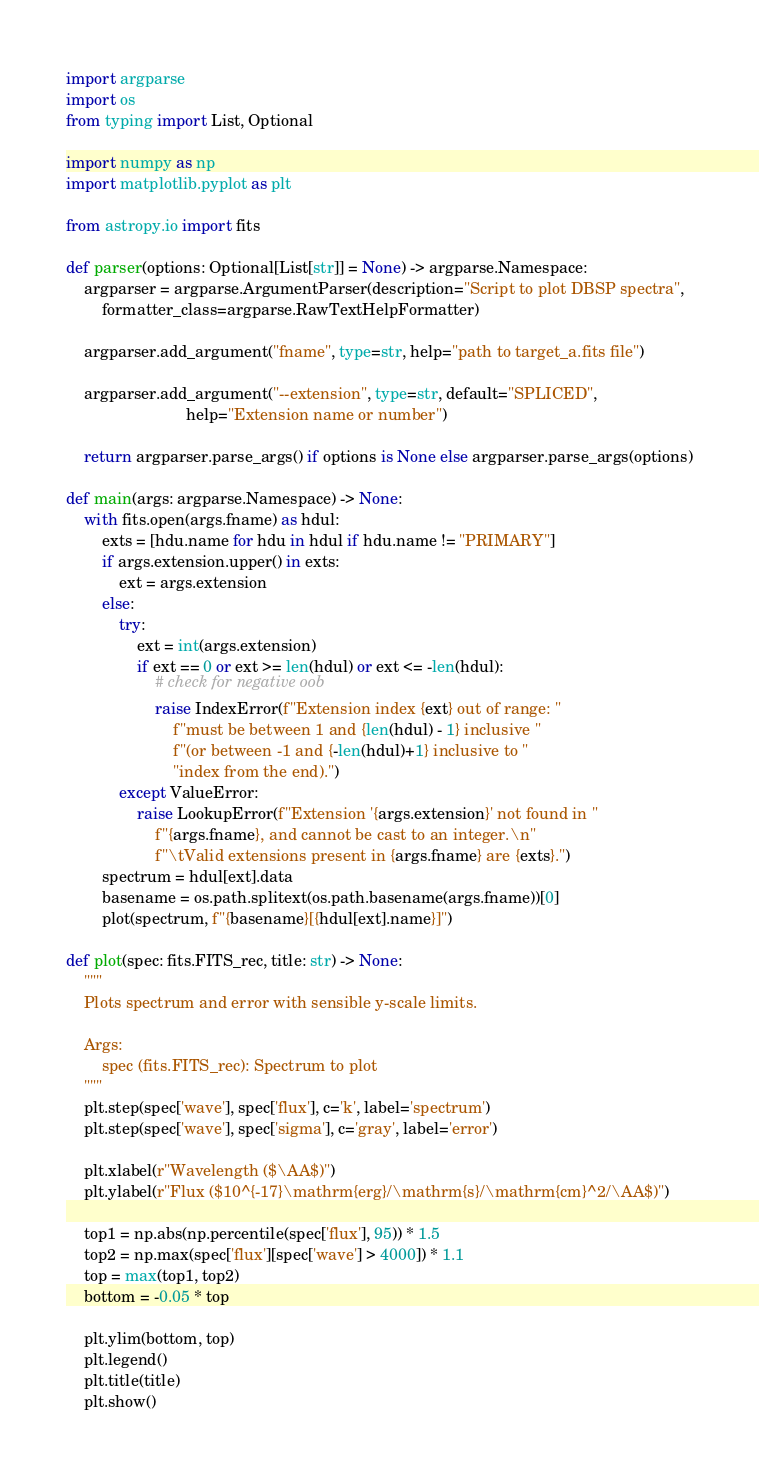<code> <loc_0><loc_0><loc_500><loc_500><_Python_>import argparse
import os
from typing import List, Optional

import numpy as np
import matplotlib.pyplot as plt

from astropy.io import fits

def parser(options: Optional[List[str]] = None) -> argparse.Namespace:
    argparser = argparse.ArgumentParser(description="Script to plot DBSP spectra",
        formatter_class=argparse.RawTextHelpFormatter)

    argparser.add_argument("fname", type=str, help="path to target_a.fits file")

    argparser.add_argument("--extension", type=str, default="SPLICED",
                           help="Extension name or number")

    return argparser.parse_args() if options is None else argparser.parse_args(options)

def main(args: argparse.Namespace) -> None:
    with fits.open(args.fname) as hdul:
        exts = [hdu.name for hdu in hdul if hdu.name != "PRIMARY"]
        if args.extension.upper() in exts:
            ext = args.extension
        else:
            try:
                ext = int(args.extension)
                if ext == 0 or ext >= len(hdul) or ext <= -len(hdul):
                    # check for negative oob
                    raise IndexError(f"Extension index {ext} out of range: "
                        f"must be between 1 and {len(hdul) - 1} inclusive "
                        f"(or between -1 and {-len(hdul)+1} inclusive to "
                        "index from the end).")
            except ValueError:
                raise LookupError(f"Extension '{args.extension}' not found in "
                    f"{args.fname}, and cannot be cast to an integer.\n"
                    f"\tValid extensions present in {args.fname} are {exts}.")
        spectrum = hdul[ext].data
        basename = os.path.splitext(os.path.basename(args.fname))[0]
        plot(spectrum, f"{basename}[{hdul[ext].name}]")

def plot(spec: fits.FITS_rec, title: str) -> None:
    """
    Plots spectrum and error with sensible y-scale limits.

    Args:
        spec (fits.FITS_rec): Spectrum to plot
    """
    plt.step(spec['wave'], spec['flux'], c='k', label='spectrum')
    plt.step(spec['wave'], spec['sigma'], c='gray', label='error')

    plt.xlabel(r"Wavelength ($\AA$)")
    plt.ylabel(r"Flux ($10^{-17}\mathrm{erg}/\mathrm{s}/\mathrm{cm}^2/\AA$)")

    top1 = np.abs(np.percentile(spec['flux'], 95)) * 1.5
    top2 = np.max(spec['flux'][spec['wave'] > 4000]) * 1.1
    top = max(top1, top2)
    bottom = -0.05 * top

    plt.ylim(bottom, top)
    plt.legend()
    plt.title(title)
    plt.show()
</code> 